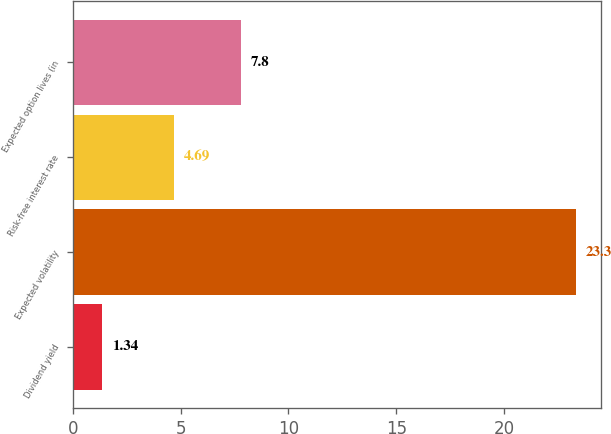Convert chart to OTSL. <chart><loc_0><loc_0><loc_500><loc_500><bar_chart><fcel>Dividend yield<fcel>Expected volatility<fcel>Risk-free interest rate<fcel>Expected option lives (in<nl><fcel>1.34<fcel>23.3<fcel>4.69<fcel>7.8<nl></chart> 